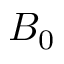<formula> <loc_0><loc_0><loc_500><loc_500>B _ { 0 }</formula> 